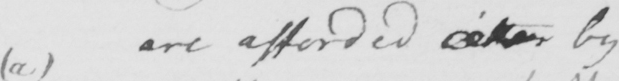Can you tell me what this handwritten text says? are afforded  <gap/>  by 